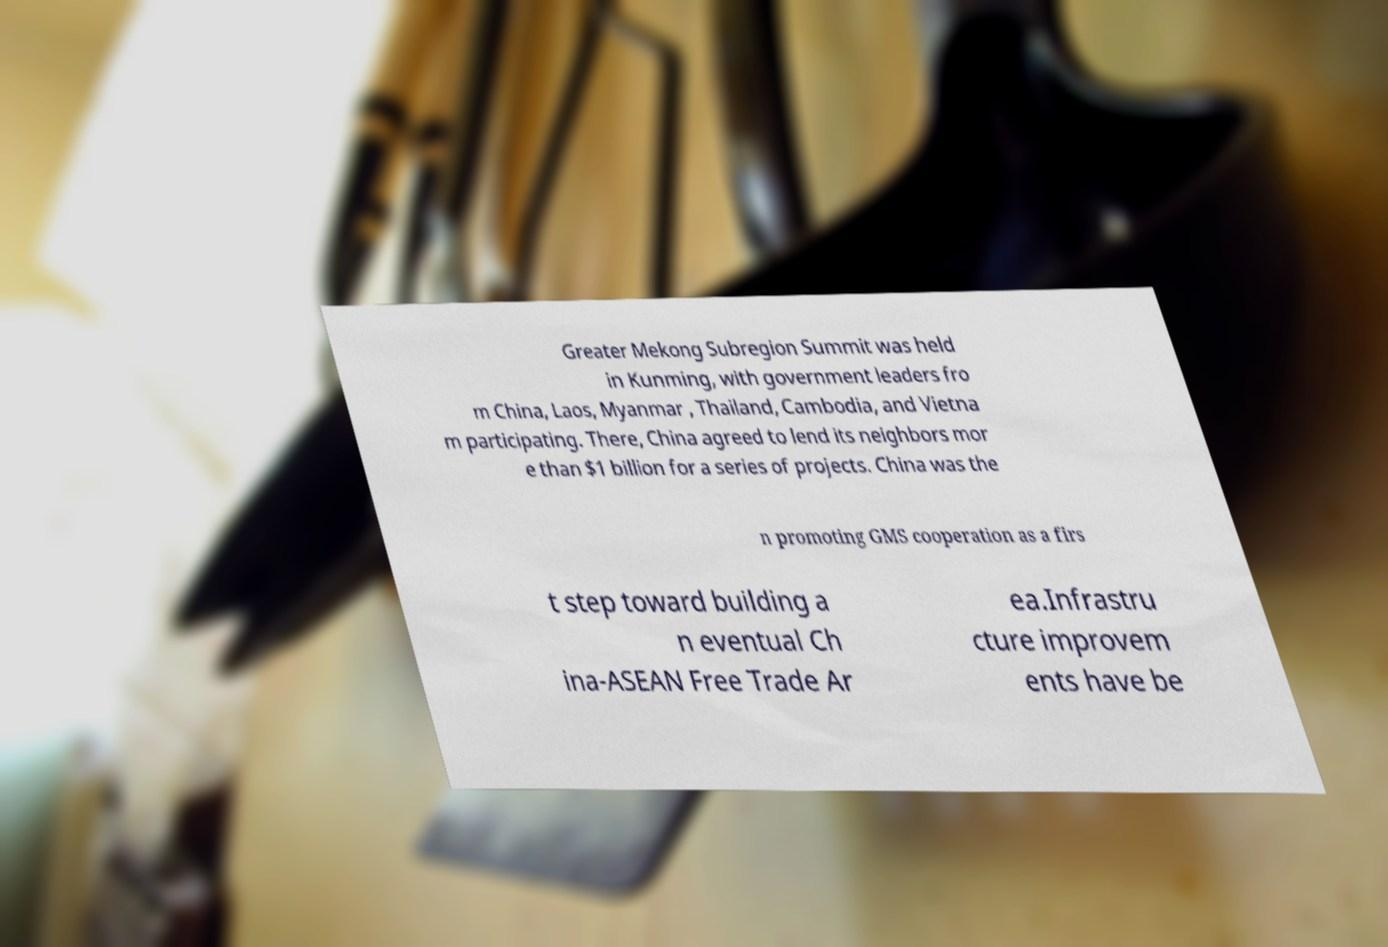Please read and relay the text visible in this image. What does it say? Greater Mekong Subregion Summit was held in Kunming, with government leaders fro m China, Laos, Myanmar , Thailand, Cambodia, and Vietna m participating. There, China agreed to lend its neighbors mor e than $1 billion for a series of projects. China was the n promoting GMS cooperation as a firs t step toward building a n eventual Ch ina-ASEAN Free Trade Ar ea.Infrastru cture improvem ents have be 